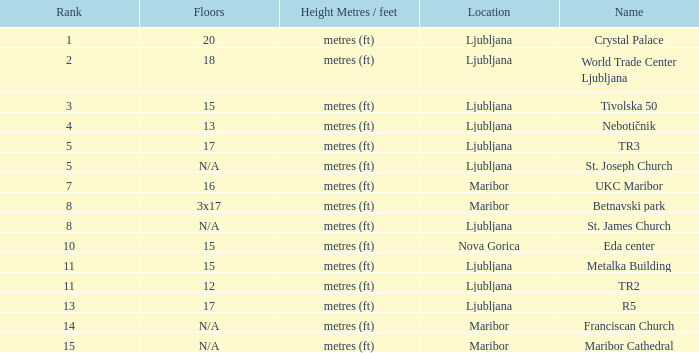Which Rank is the lowest one that has a Name of maribor cathedral? 15.0. 